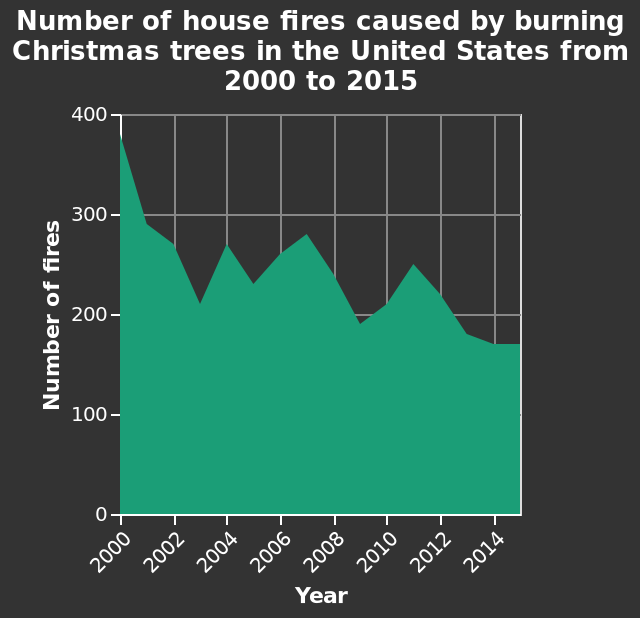<image>
Which variable is plotted along the x-axis? The year is plotted along the x-axis. please summary the statistics and relations of the chart The general trend shows a reduction in fires since between 2000 and 2015. Fires increased compared to the previous year in years 2004, 2006, 2007, 2010 and 2011. During what time period did the reduction in fires occur? The reduction in fires occurred between 2000 and 2015. 